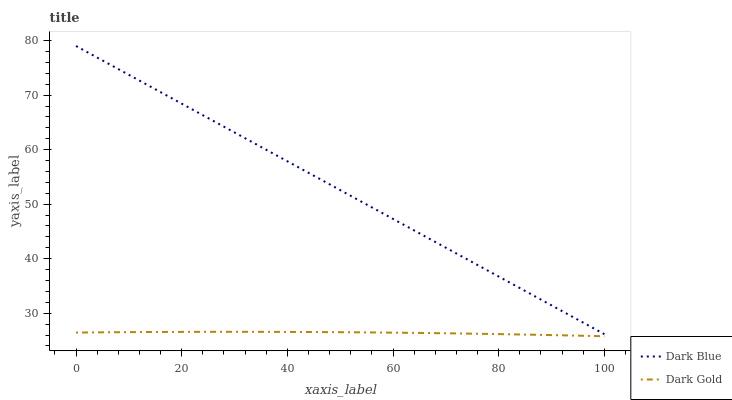Does Dark Gold have the maximum area under the curve?
Answer yes or no. No. Is Dark Gold the smoothest?
Answer yes or no. No. Does Dark Gold have the highest value?
Answer yes or no. No. Is Dark Gold less than Dark Blue?
Answer yes or no. Yes. Is Dark Blue greater than Dark Gold?
Answer yes or no. Yes. Does Dark Gold intersect Dark Blue?
Answer yes or no. No. 